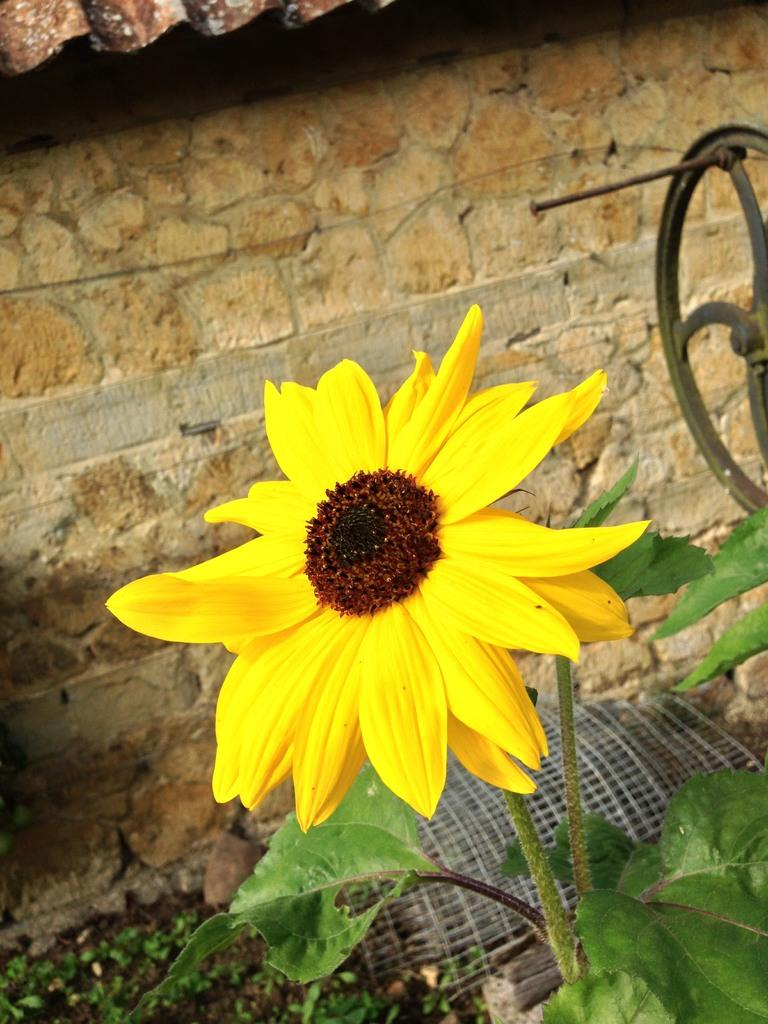What is the main subject in the foreground of the image? There is a yellow flower in the foreground of the image. What is the yellow flower situated on? The yellow flower is on a plant. What can be seen in the background of the image? There are plants and a metal mesh in the background of the image. What type of structure is visible in the background? There is a wall of a hut in the background of the image. What object is located on the right side of the image? There is a metal wheel on the right side of the image. How many letters are visible on the metal wheel in the image? There are no letters visible on the metal wheel in the image. What type of laborer is working on the hut in the background of the image? There is no laborer present in the image; it only shows a wall of a hut in the background. 